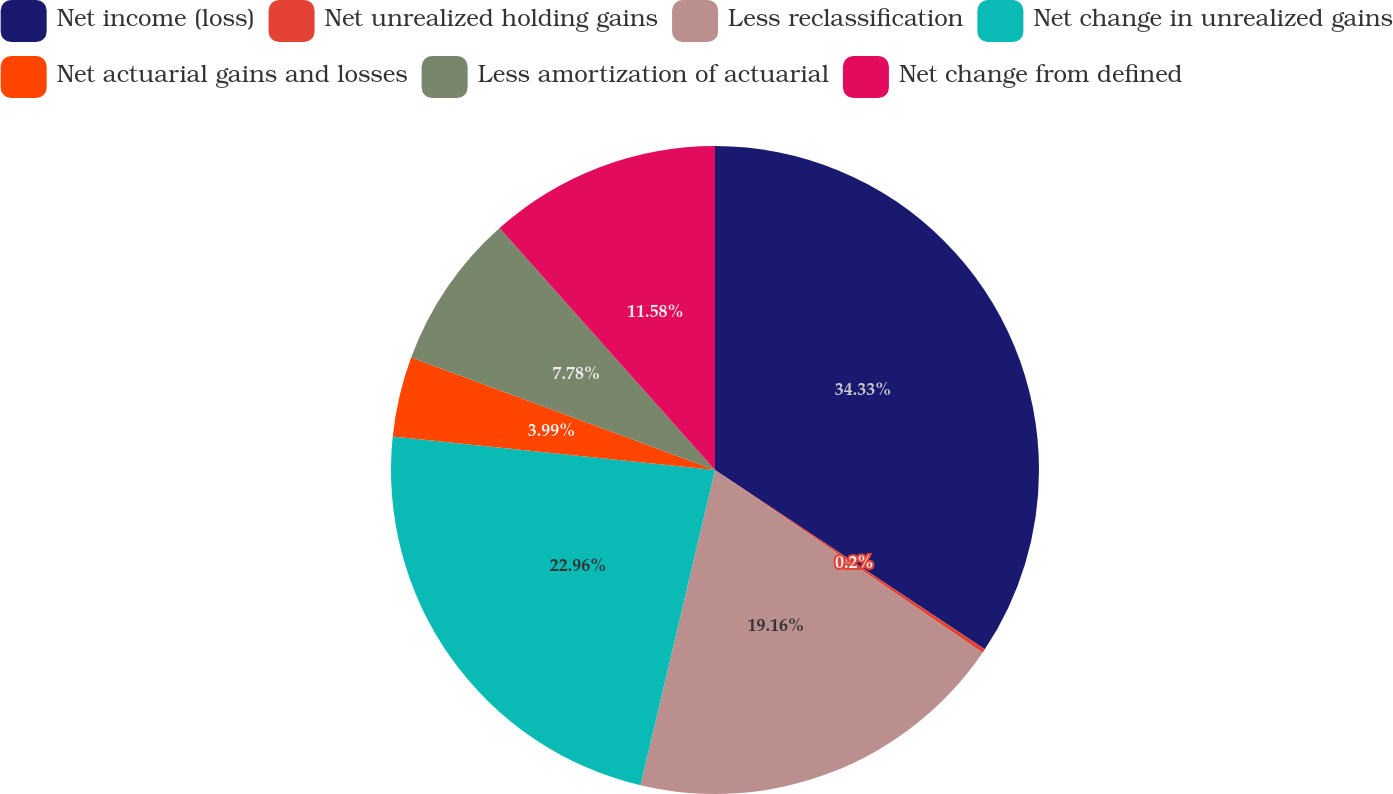Convert chart to OTSL. <chart><loc_0><loc_0><loc_500><loc_500><pie_chart><fcel>Net income (loss)<fcel>Net unrealized holding gains<fcel>Less reclassification<fcel>Net change in unrealized gains<fcel>Net actuarial gains and losses<fcel>Less amortization of actuarial<fcel>Net change from defined<nl><fcel>34.34%<fcel>0.2%<fcel>19.16%<fcel>22.96%<fcel>3.99%<fcel>7.78%<fcel>11.58%<nl></chart> 